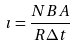<formula> <loc_0><loc_0><loc_500><loc_500>\imath = \frac { N B A } { R \Delta t }</formula> 